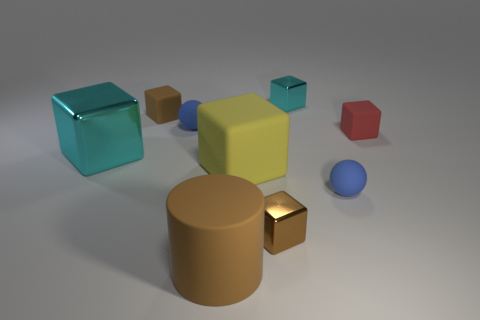Are these objects arranged in a specific pattern or randomly? The objects in the image seem to be arranged deliberately but not in a strict pattern. They are scattered across the surface with ample space between each other, allowing each object to be distinctly visible. This layout may suggest an aesthetic or functional purpose, perhaps in an educational setting where the objects could be used to demonstrate geometric shapes and properties. 